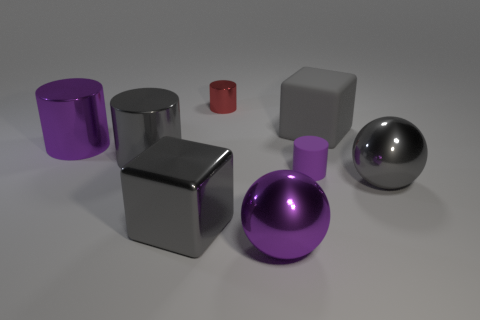Add 2 matte cylinders. How many objects exist? 10 Subtract all balls. How many objects are left? 6 Add 7 large purple metallic balls. How many large purple metallic balls are left? 8 Add 6 purple cylinders. How many purple cylinders exist? 8 Subtract 0 red spheres. How many objects are left? 8 Subtract all purple rubber objects. Subtract all tiny cyan shiny blocks. How many objects are left? 7 